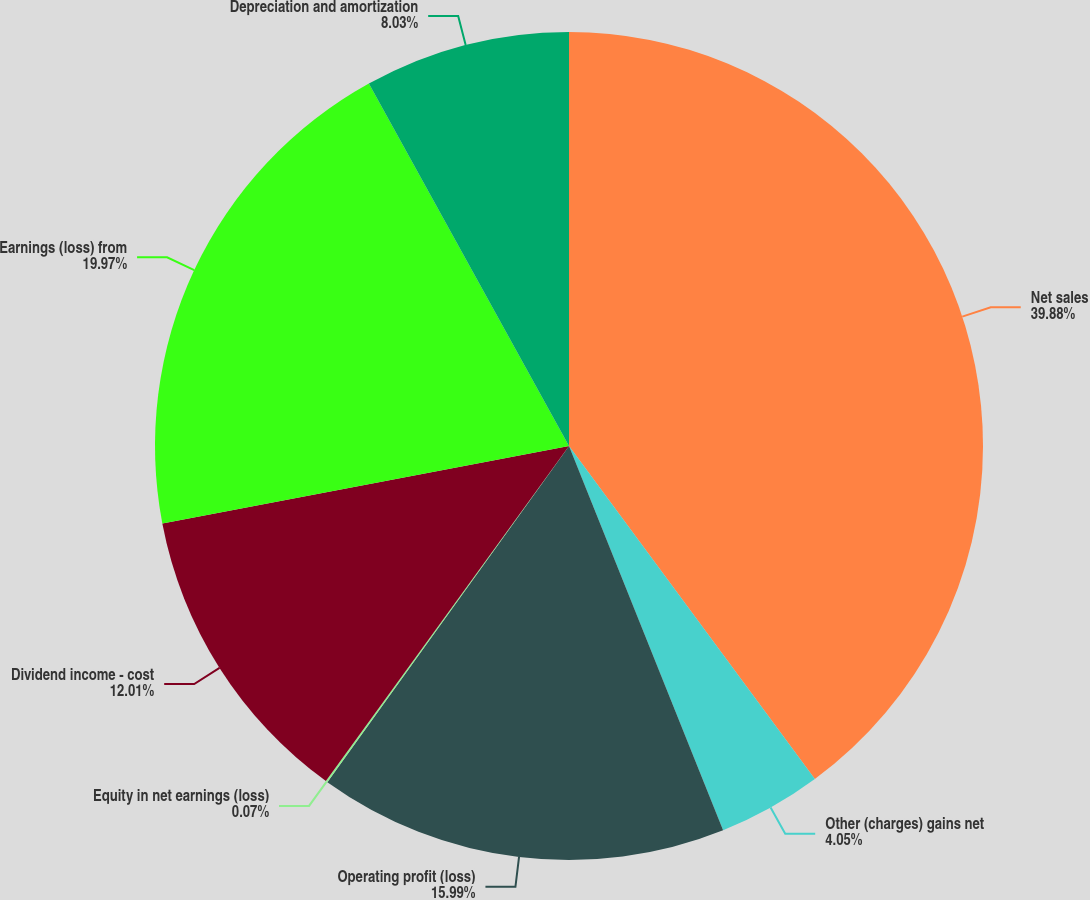Convert chart to OTSL. <chart><loc_0><loc_0><loc_500><loc_500><pie_chart><fcel>Net sales<fcel>Other (charges) gains net<fcel>Operating profit (loss)<fcel>Equity in net earnings (loss)<fcel>Dividend income - cost<fcel>Earnings (loss) from<fcel>Depreciation and amortization<nl><fcel>39.88%<fcel>4.05%<fcel>15.99%<fcel>0.07%<fcel>12.01%<fcel>19.97%<fcel>8.03%<nl></chart> 